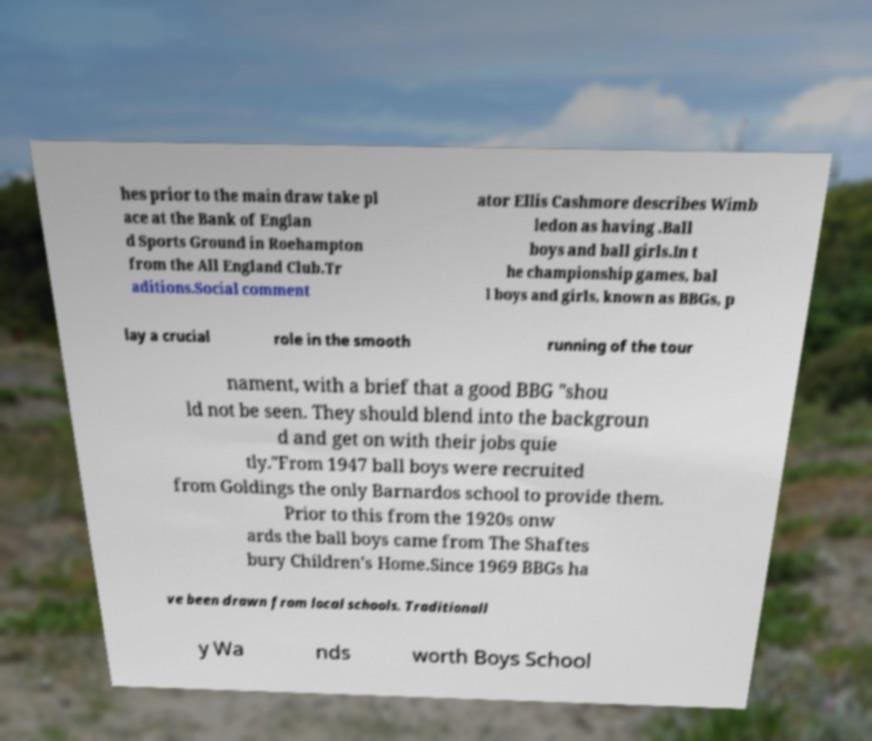Could you assist in decoding the text presented in this image and type it out clearly? hes prior to the main draw take pl ace at the Bank of Englan d Sports Ground in Roehampton from the All England Club.Tr aditions.Social comment ator Ellis Cashmore describes Wimb ledon as having .Ball boys and ball girls.In t he championship games, bal l boys and girls, known as BBGs, p lay a crucial role in the smooth running of the tour nament, with a brief that a good BBG "shou ld not be seen. They should blend into the backgroun d and get on with their jobs quie tly."From 1947 ball boys were recruited from Goldings the only Barnardos school to provide them. Prior to this from the 1920s onw ards the ball boys came from The Shaftes bury Children's Home.Since 1969 BBGs ha ve been drawn from local schools. Traditionall y Wa nds worth Boys School 